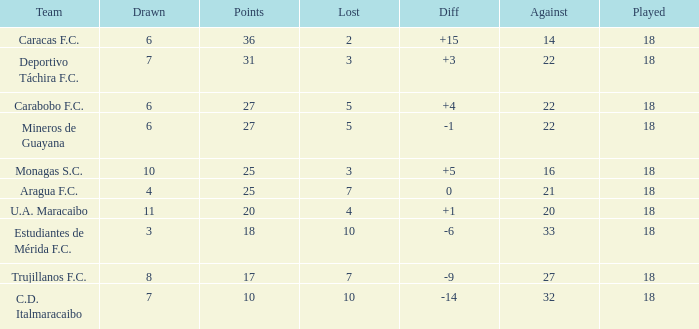What is the sum of the points of all teams that had against scores less than 14? None. 